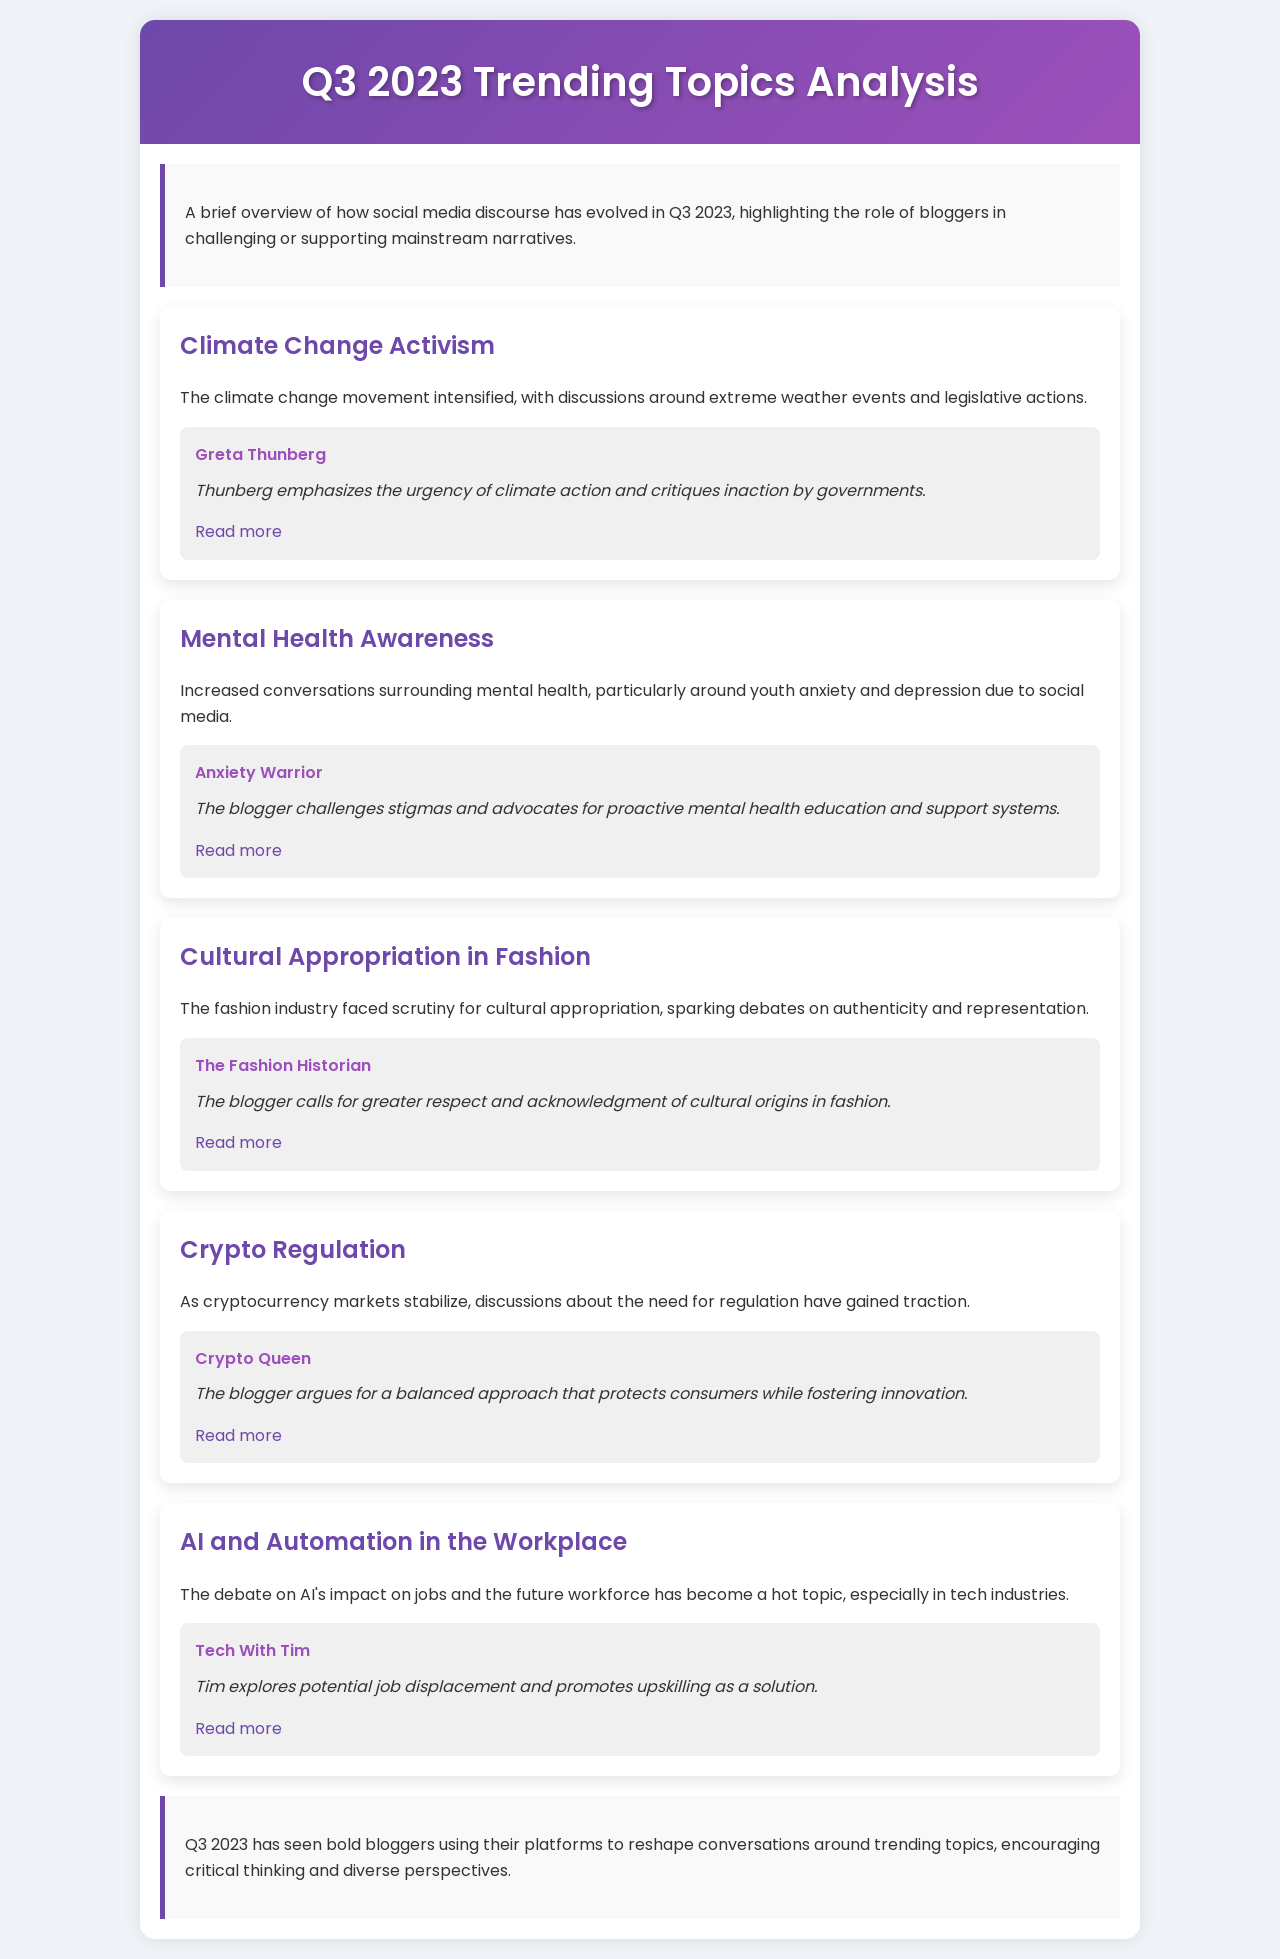what is the title of the document? The title of the document is provided in the header section and is "Q3 2023 Trending Topics Analysis".
Answer: Q3 2023 Trending Topics Analysis who is the blogger that emphasizes the urgency of climate action? The blogger highlighting the urgency of climate action is mentioned in the section about Climate Change Activism.
Answer: Greta Thunberg which topic discusses youth anxiety and depression? The topic specifically addressing youth anxiety and depression is found in the section on Mental Health Awareness.
Answer: Mental Health Awareness how many topics are covered in the document? The number of topics can be counted from the different sections presented in the document.
Answer: Five what key message does the Fashion Historian present? The key message from the Fashion Historian is found in the corresponding section discussing cultural appropriation.
Answer: Greater respect and acknowledgment of cultural origins in fashion which blogger argues for balanced consumer protection in cryptocurrency? The document highlights a specific blogger that argues for balanced consumer protection in the section on Crypto Regulation.
Answer: Crypto Queen what is a common theme among the bloggers mentioned? The common theme can be inferred from the contributions of the bloggers, especially related to challenging mainstream views.
Answer: Advocating for awareness and action what does Tech With Tim promote as a solution to job displacement? The document indicates what Tech With Tim suggests as a solution in the AI and Automation section.
Answer: Upskilling 